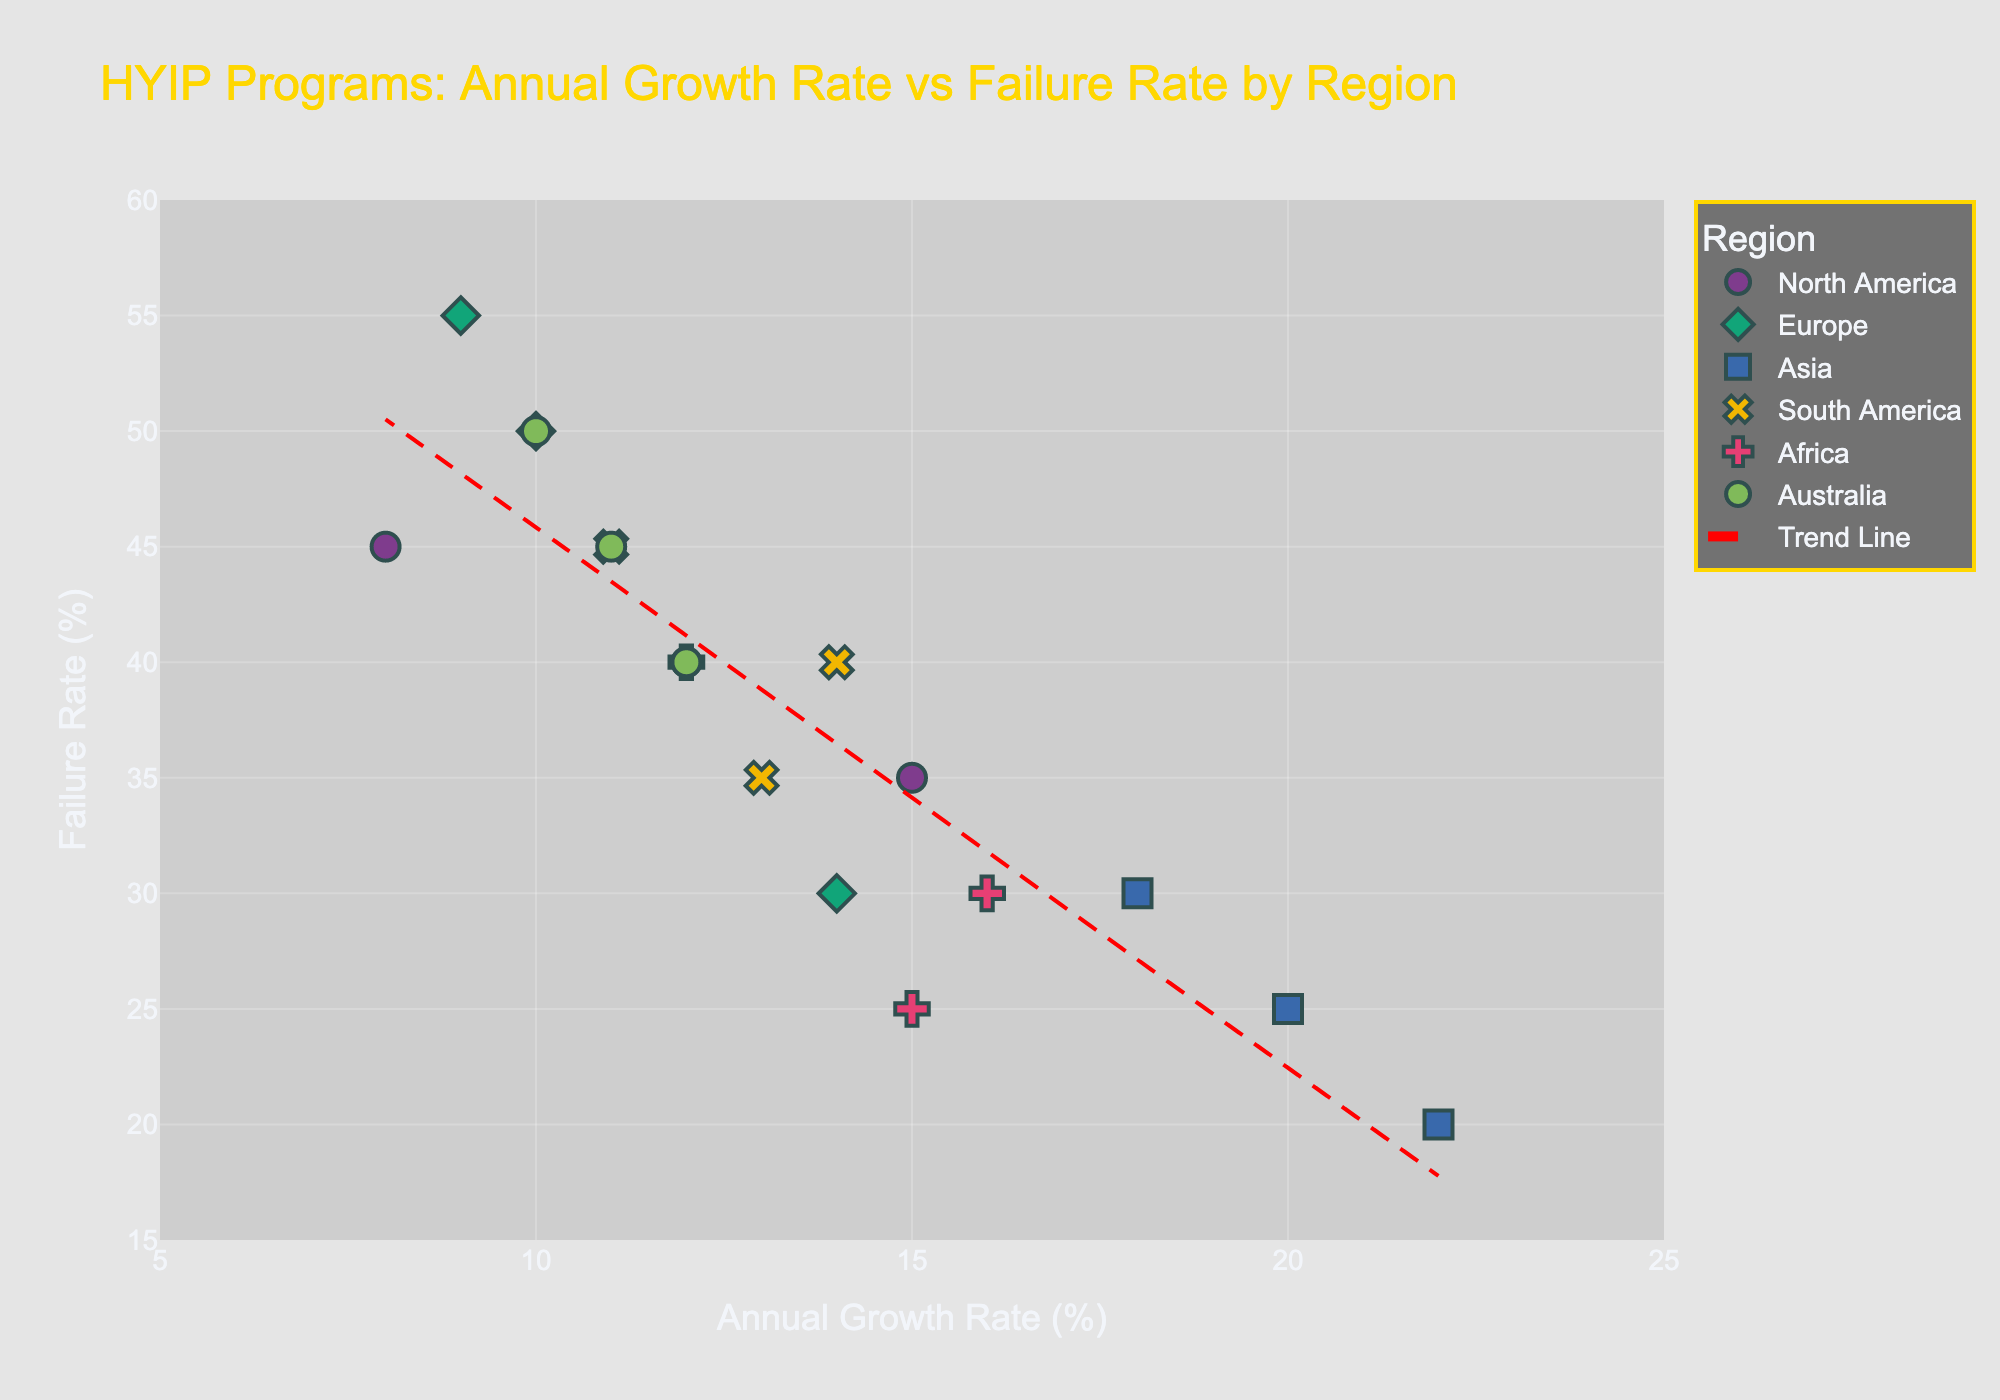How many regions are represented in the scatter plot? Identify the number of unique colors or symbols that denote different regions presented in the legend.
Answer: 6 Which region has the highest Annual Growth Rate? Observe the x-axis values and identify the point furthest to the right. Hover over this point to determine its region.
Answer: Asia What is the Failure Rate for "Eco Investments" in Europe? Locate "Eco Investments" by hovering over the points in the Europe region and identify its corresponding y-axis value.
Answer: 55% Which region has the program with the highest Failure Rate? Observe the y-axis values and identify the highest point. Hover over this point to determine its region.
Answer: Europe What is the average Annual Growth Rate for programs in Africa? Find the points corresponding to Africa, sum up their x-axis values, and divide by the number of points. (16 + 12 + 15) / 3 = 14.33
Answer: 14.33% Which region has the lowest Failure Rate for its programs on average? Calculate the average Failure Rate for each region by summing up the y-axis values of the points in that region and dividing by the number of points. Compare these averages.
Answer: Asia Compare the Annual Growth Rates of "Zenith Growth" and "Golden Invest". Which one is higher? Locate the points for "Zenith Growth" and "Golden Invest" by hovering over them and compare their x-axis values.
Answer: Zenith Growth What's the range of Annual Growth Rates for HYIP programs in South America? Identify the HYIP programs in South America and note the minimum and maximum x-axis values among them. Minimum is 11% and maximum is 14%, so the range is 14 - 11 = 3.
Answer: 3% What is the trend shown by the trend line added to the scatter plot? Observe the direction of the trend line, which fits the data points. Determine whether it slopes upward or downward.
Answer: Upward How does the Annual Growth Rate of "OzInvest" compare with the overall trend line? Locate "OzInvest" and observe its position relative to the trend line; check whether it is above or below the line.
Answer: Above 